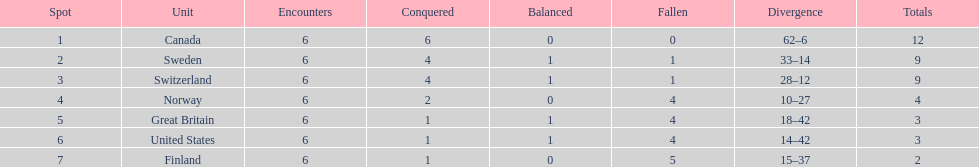Which team positioned after sweden? Switzerland. 